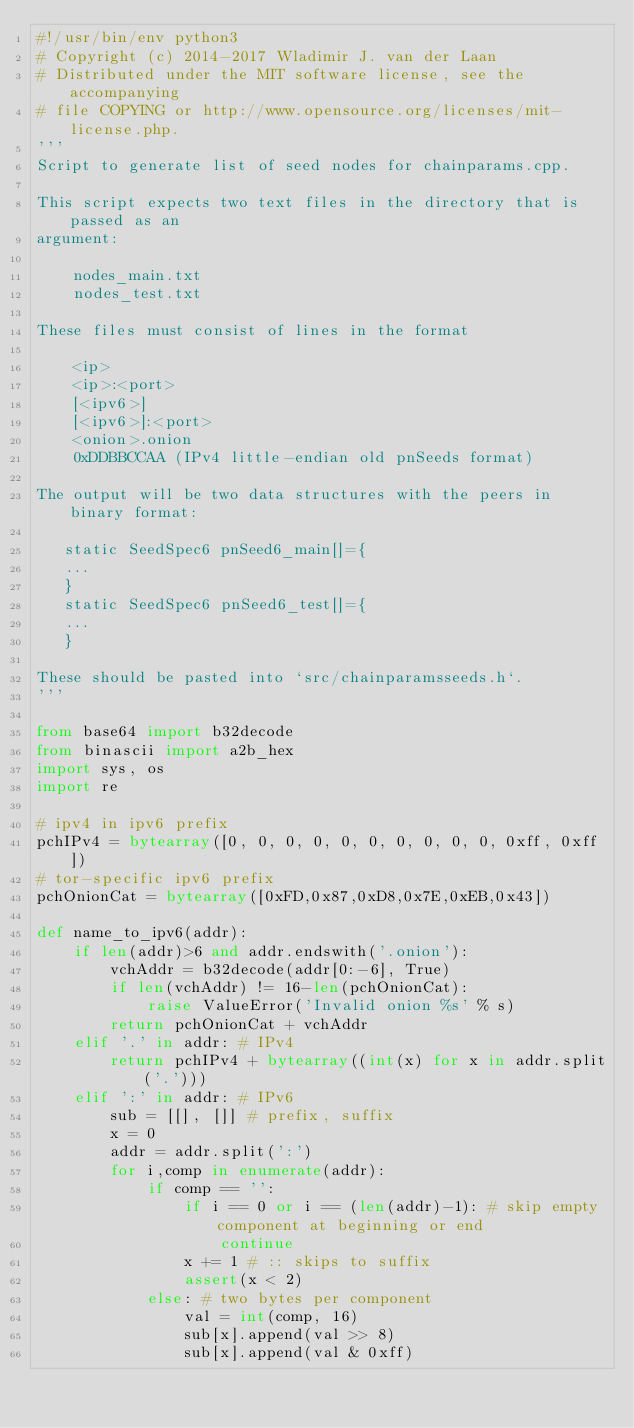Convert code to text. <code><loc_0><loc_0><loc_500><loc_500><_Python_>#!/usr/bin/env python3
# Copyright (c) 2014-2017 Wladimir J. van der Laan
# Distributed under the MIT software license, see the accompanying
# file COPYING or http://www.opensource.org/licenses/mit-license.php.
'''
Script to generate list of seed nodes for chainparams.cpp.

This script expects two text files in the directory that is passed as an
argument:

    nodes_main.txt
    nodes_test.txt

These files must consist of lines in the format

    <ip>
    <ip>:<port>
    [<ipv6>]
    [<ipv6>]:<port>
    <onion>.onion
    0xDDBBCCAA (IPv4 little-endian old pnSeeds format)

The output will be two data structures with the peers in binary format:

   static SeedSpec6 pnSeed6_main[]={
   ...
   }
   static SeedSpec6 pnSeed6_test[]={
   ...
   }

These should be pasted into `src/chainparamsseeds.h`.
'''

from base64 import b32decode
from binascii import a2b_hex
import sys, os
import re

# ipv4 in ipv6 prefix
pchIPv4 = bytearray([0, 0, 0, 0, 0, 0, 0, 0, 0, 0, 0xff, 0xff])
# tor-specific ipv6 prefix
pchOnionCat = bytearray([0xFD,0x87,0xD8,0x7E,0xEB,0x43])

def name_to_ipv6(addr):
    if len(addr)>6 and addr.endswith('.onion'):
        vchAddr = b32decode(addr[0:-6], True)
        if len(vchAddr) != 16-len(pchOnionCat):
            raise ValueError('Invalid onion %s' % s)
        return pchOnionCat + vchAddr
    elif '.' in addr: # IPv4
        return pchIPv4 + bytearray((int(x) for x in addr.split('.')))
    elif ':' in addr: # IPv6
        sub = [[], []] # prefix, suffix
        x = 0
        addr = addr.split(':')
        for i,comp in enumerate(addr):
            if comp == '':
                if i == 0 or i == (len(addr)-1): # skip empty component at beginning or end
                    continue
                x += 1 # :: skips to suffix
                assert(x < 2)
            else: # two bytes per component
                val = int(comp, 16)
                sub[x].append(val >> 8)
                sub[x].append(val & 0xff)</code> 